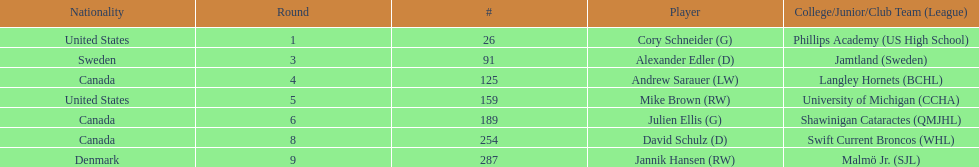List only the american players. Cory Schneider (G), Mike Brown (RW). 